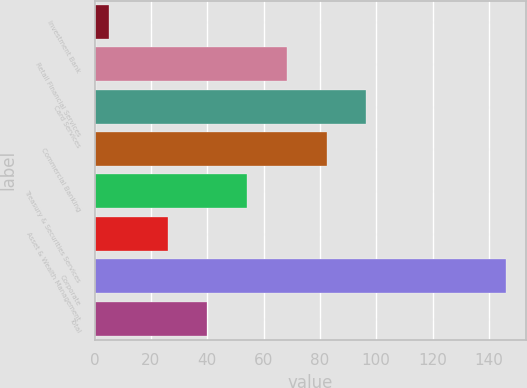Convert chart to OTSL. <chart><loc_0><loc_0><loc_500><loc_500><bar_chart><fcel>Investment Bank<fcel>Retail Financial Services<fcel>Card Services<fcel>Commercial Banking<fcel>Treasury & Securities Services<fcel>Asset & Wealth Management<fcel>Corporate<fcel>Total<nl><fcel>5<fcel>68.3<fcel>96.5<fcel>82.4<fcel>54.2<fcel>26<fcel>146<fcel>40.1<nl></chart> 